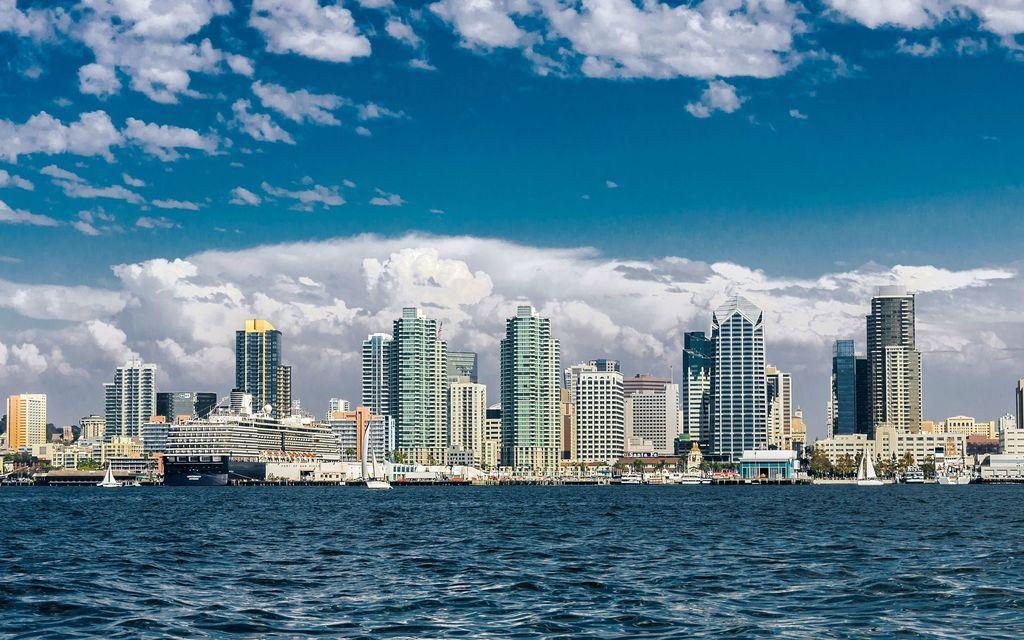Can you describe this image briefly? In this image there are boats sailing on the surface of the water. Background there are trees and buildings. Top of the image there is sky with some clouds. 